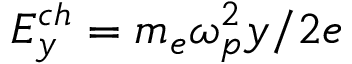Convert formula to latex. <formula><loc_0><loc_0><loc_500><loc_500>E _ { y } ^ { c h } = m _ { e } \omega _ { p } ^ { 2 } y / 2 e</formula> 